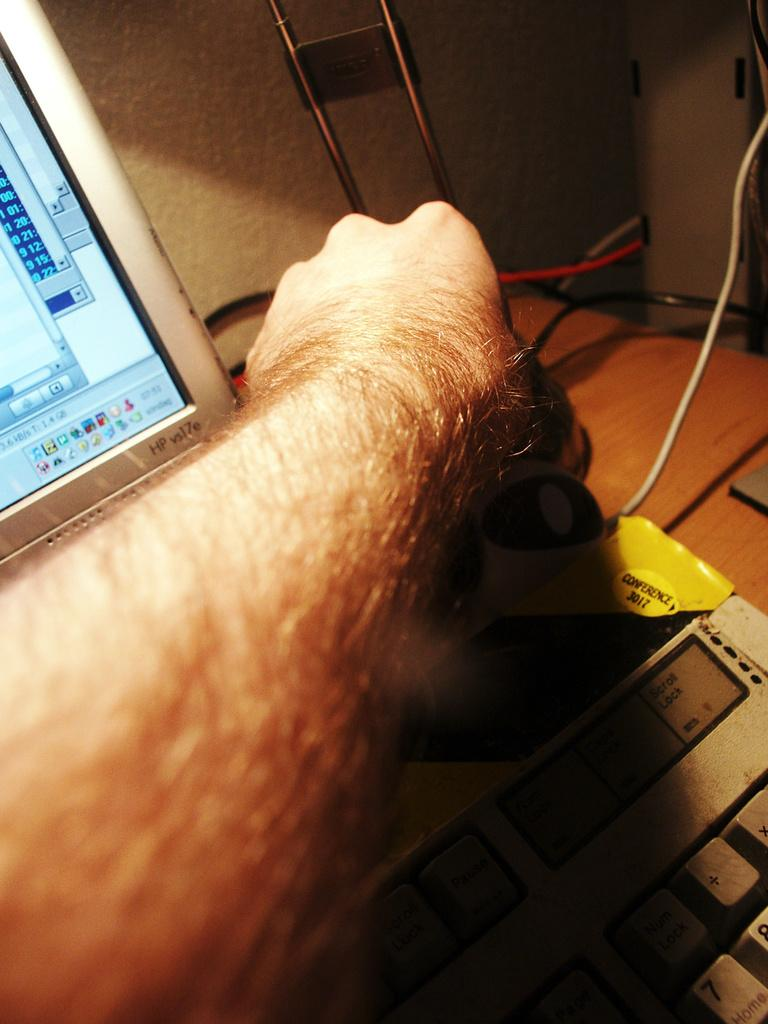Provide a one-sentence caption for the provided image. An HP vs17e monitor sits on a wood desk. 